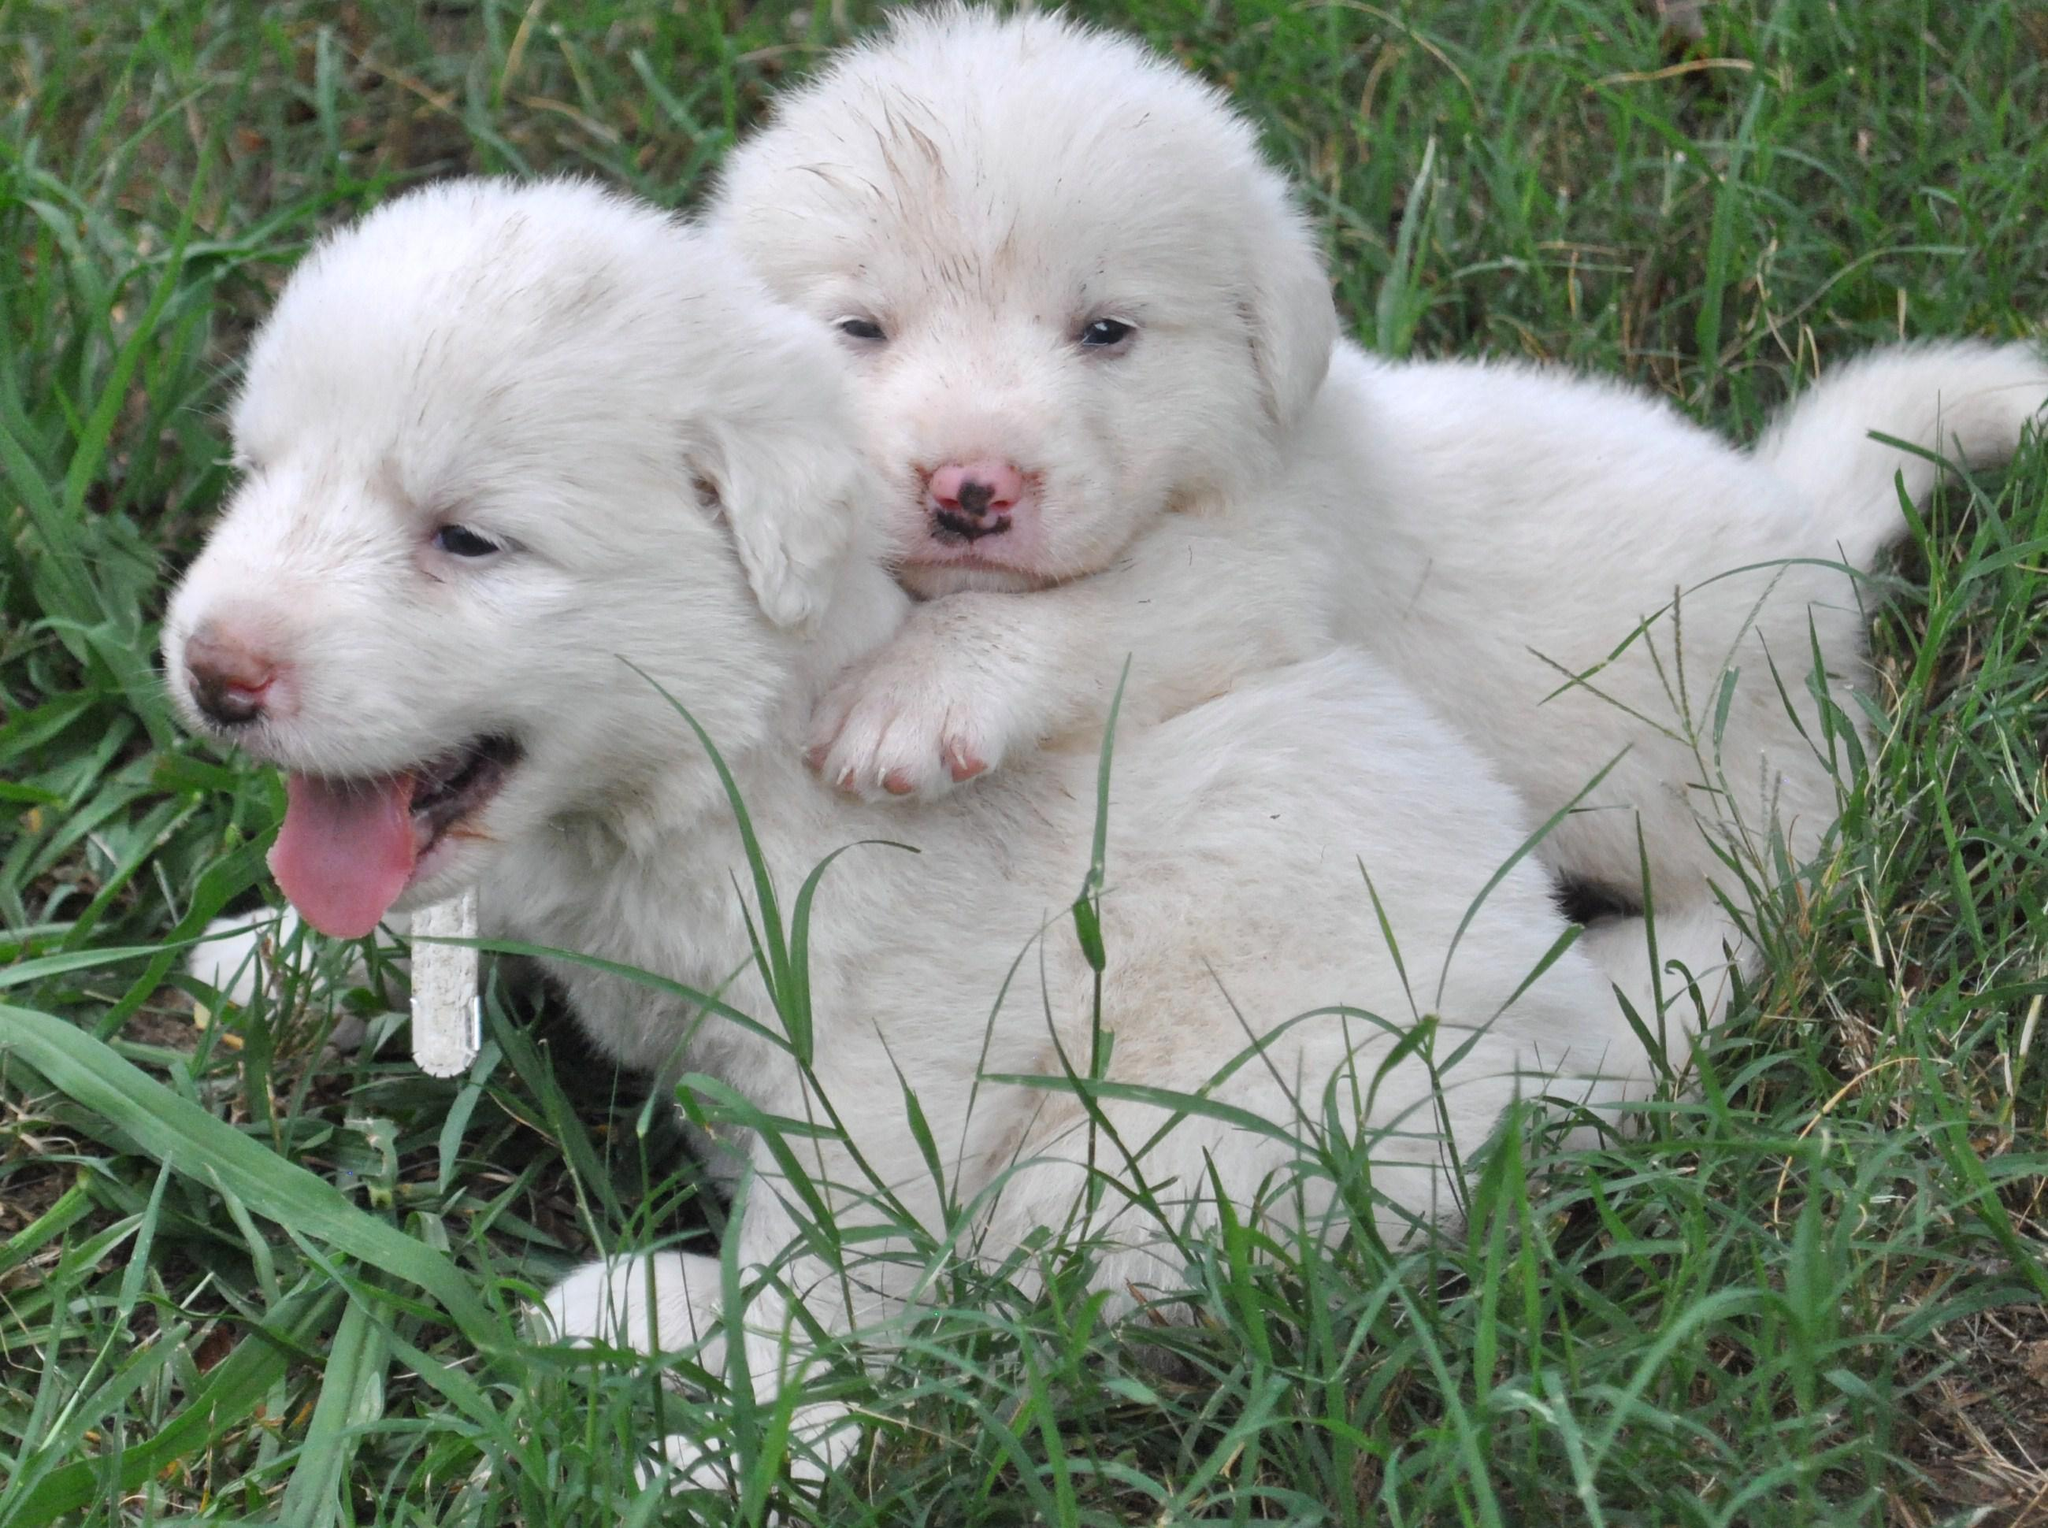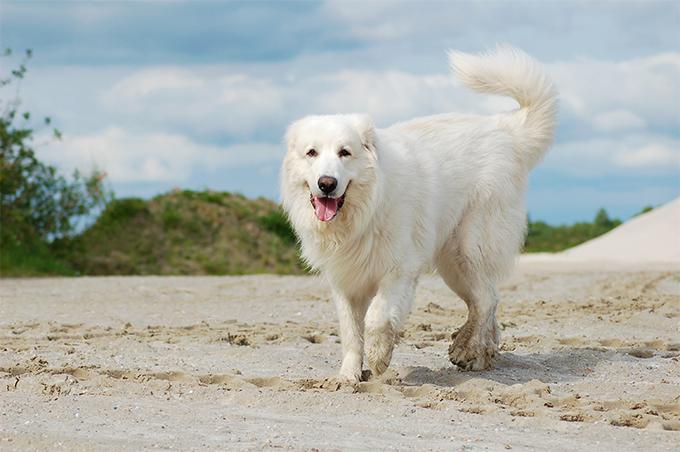The first image is the image on the left, the second image is the image on the right. Examine the images to the left and right. Is the description "There is a total of four dogs." accurate? Answer yes or no. No. 